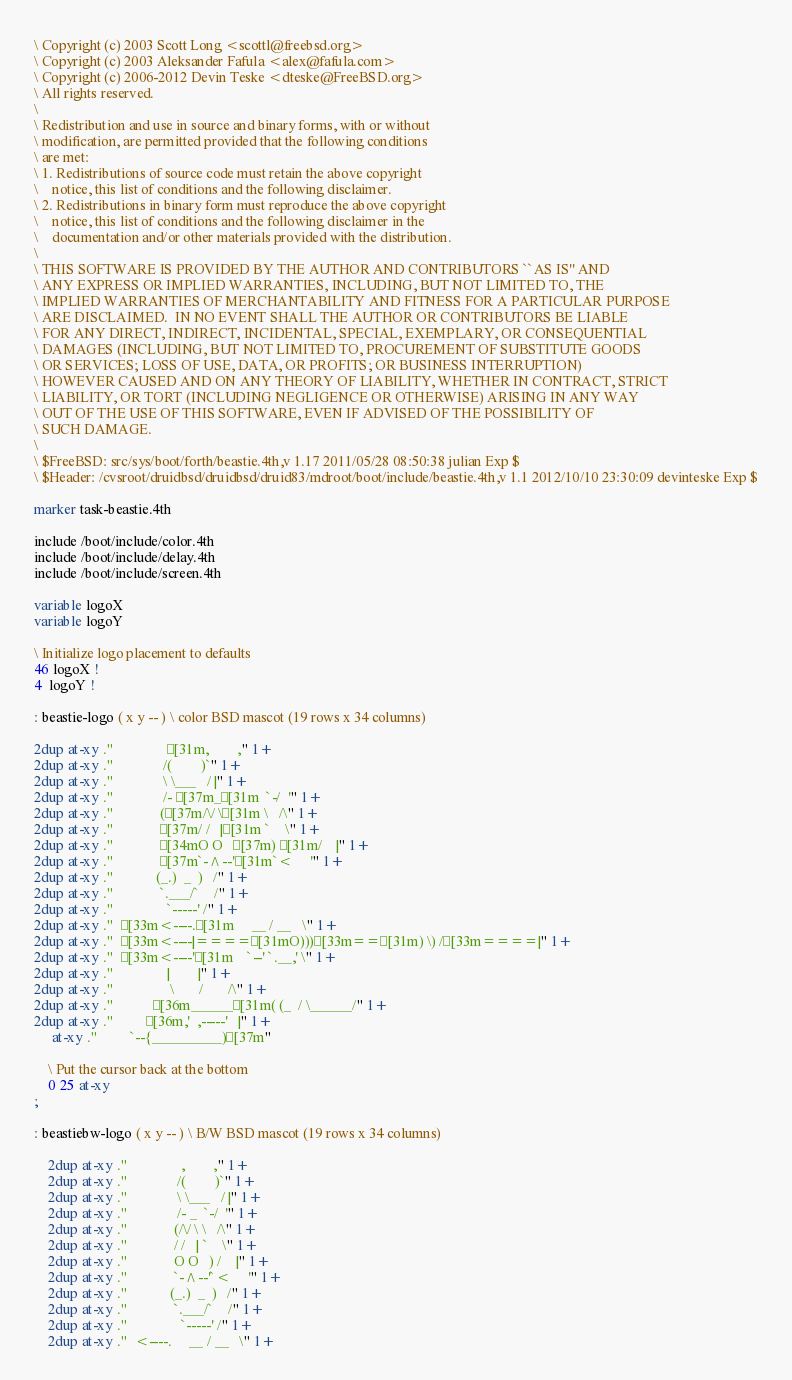<code> <loc_0><loc_0><loc_500><loc_500><_Forth_>\ Copyright (c) 2003 Scott Long <scottl@freebsd.org>
\ Copyright (c) 2003 Aleksander Fafula <alex@fafula.com>
\ Copyright (c) 2006-2012 Devin Teske <dteske@FreeBSD.org>
\ All rights reserved.
\ 
\ Redistribution and use in source and binary forms, with or without
\ modification, are permitted provided that the following conditions
\ are met:
\ 1. Redistributions of source code must retain the above copyright
\    notice, this list of conditions and the following disclaimer.
\ 2. Redistributions in binary form must reproduce the above copyright
\    notice, this list of conditions and the following disclaimer in the
\    documentation and/or other materials provided with the distribution.
\ 
\ THIS SOFTWARE IS PROVIDED BY THE AUTHOR AND CONTRIBUTORS ``AS IS'' AND
\ ANY EXPRESS OR IMPLIED WARRANTIES, INCLUDING, BUT NOT LIMITED TO, THE
\ IMPLIED WARRANTIES OF MERCHANTABILITY AND FITNESS FOR A PARTICULAR PURPOSE
\ ARE DISCLAIMED.  IN NO EVENT SHALL THE AUTHOR OR CONTRIBUTORS BE LIABLE
\ FOR ANY DIRECT, INDIRECT, INCIDENTAL, SPECIAL, EXEMPLARY, OR CONSEQUENTIAL
\ DAMAGES (INCLUDING, BUT NOT LIMITED TO, PROCUREMENT OF SUBSTITUTE GOODS
\ OR SERVICES; LOSS OF USE, DATA, OR PROFITS; OR BUSINESS INTERRUPTION)
\ HOWEVER CAUSED AND ON ANY THEORY OF LIABILITY, WHETHER IN CONTRACT, STRICT
\ LIABILITY, OR TORT (INCLUDING NEGLIGENCE OR OTHERWISE) ARISING IN ANY WAY
\ OUT OF THE USE OF THIS SOFTWARE, EVEN IF ADVISED OF THE POSSIBILITY OF
\ SUCH DAMAGE.
\ 
\ $FreeBSD: src/sys/boot/forth/beastie.4th,v 1.17 2011/05/28 08:50:38 julian Exp $
\ $Header: /cvsroot/druidbsd/druidbsd/druid83/mdroot/boot/include/beastie.4th,v 1.1 2012/10/10 23:30:09 devinteske Exp $

marker task-beastie.4th

include /boot/include/color.4th
include /boot/include/delay.4th
include /boot/include/screen.4th

variable logoX
variable logoY

\ Initialize logo placement to defaults
46 logoX !
4  logoY !

: beastie-logo ( x y -- ) \ color BSD mascot (19 rows x 34 columns)

2dup at-xy ."               [31m,        ," 1+
2dup at-xy ."              /(        )`" 1+
2dup at-xy ."              \ \___   / |" 1+
2dup at-xy ."              /- [37m_[31m  `-/  '" 1+
2dup at-xy ."             ([37m/\/ \[31m \   /\" 1+
2dup at-xy ."             [37m/ /   |[31m `    \" 1+
2dup at-xy ."             [34mO O   [37m) [31m/    |" 1+
2dup at-xy ."             [37m`-^--'[31m`<     '" 1+
2dup at-xy ."            (_.)  _  )   /" 1+
2dup at-xy ."             `.___/`    /" 1+
2dup at-xy ."               `-----' /" 1+
2dup at-xy ."  [33m<----.[31m     __ / __   \" 1+
2dup at-xy ."  [33m<----|====[31mO)))[33m==[31m) \) /[33m====|" 1+
2dup at-xy ."  [33m<----'[31m    `--' `.__,' \" 1+
2dup at-xy ."               |        |" 1+
2dup at-xy ."                \       /       /\" 1+
2dup at-xy ."           [36m______[31m( (_  / \______/" 1+
2dup at-xy ."         [36m,'  ,-----'   |" 1+
     at-xy ."         `--{__________)[37m"

	\ Put the cursor back at the bottom
	0 25 at-xy
;

: beastiebw-logo ( x y -- ) \ B/W BSD mascot (19 rows x 34 columns)

	2dup at-xy ."               ,        ," 1+
	2dup at-xy ."              /(        )`" 1+
	2dup at-xy ."              \ \___   / |" 1+
	2dup at-xy ."              /- _  `-/  '" 1+
	2dup at-xy ."             (/\/ \ \   /\" 1+
	2dup at-xy ."             / /   | `    \" 1+
	2dup at-xy ."             O O   ) /    |" 1+
	2dup at-xy ."             `-^--'`<     '" 1+
	2dup at-xy ."            (_.)  _  )   /" 1+
	2dup at-xy ."             `.___/`    /" 1+
	2dup at-xy ."               `-----' /" 1+
	2dup at-xy ."  <----.     __ / __   \" 1+</code> 